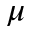Convert formula to latex. <formula><loc_0><loc_0><loc_500><loc_500>\mu</formula> 